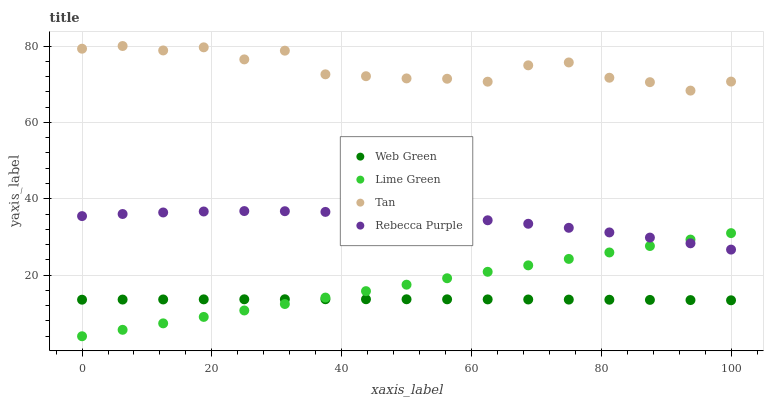Does Web Green have the minimum area under the curve?
Answer yes or no. Yes. Does Tan have the maximum area under the curve?
Answer yes or no. Yes. Does Lime Green have the minimum area under the curve?
Answer yes or no. No. Does Lime Green have the maximum area under the curve?
Answer yes or no. No. Is Lime Green the smoothest?
Answer yes or no. Yes. Is Tan the roughest?
Answer yes or no. Yes. Is Rebecca Purple the smoothest?
Answer yes or no. No. Is Rebecca Purple the roughest?
Answer yes or no. No. Does Lime Green have the lowest value?
Answer yes or no. Yes. Does Rebecca Purple have the lowest value?
Answer yes or no. No. Does Tan have the highest value?
Answer yes or no. Yes. Does Lime Green have the highest value?
Answer yes or no. No. Is Lime Green less than Tan?
Answer yes or no. Yes. Is Tan greater than Web Green?
Answer yes or no. Yes. Does Rebecca Purple intersect Lime Green?
Answer yes or no. Yes. Is Rebecca Purple less than Lime Green?
Answer yes or no. No. Is Rebecca Purple greater than Lime Green?
Answer yes or no. No. Does Lime Green intersect Tan?
Answer yes or no. No. 